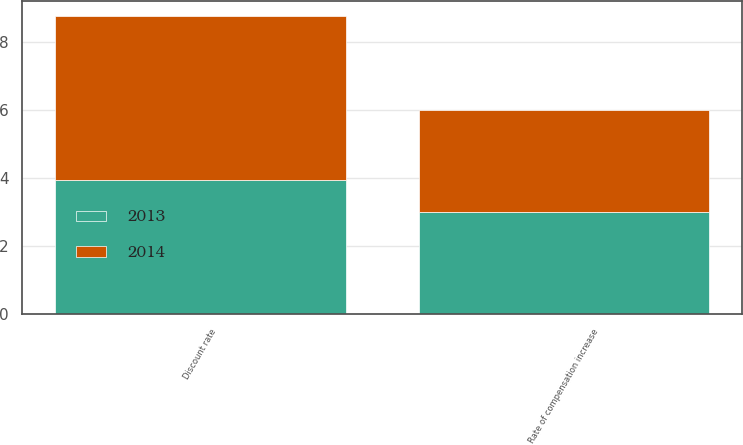Convert chart. <chart><loc_0><loc_0><loc_500><loc_500><stacked_bar_chart><ecel><fcel>Discount rate<fcel>Rate of compensation increase<nl><fcel>2013<fcel>3.95<fcel>3<nl><fcel>2014<fcel>4.8<fcel>3<nl></chart> 